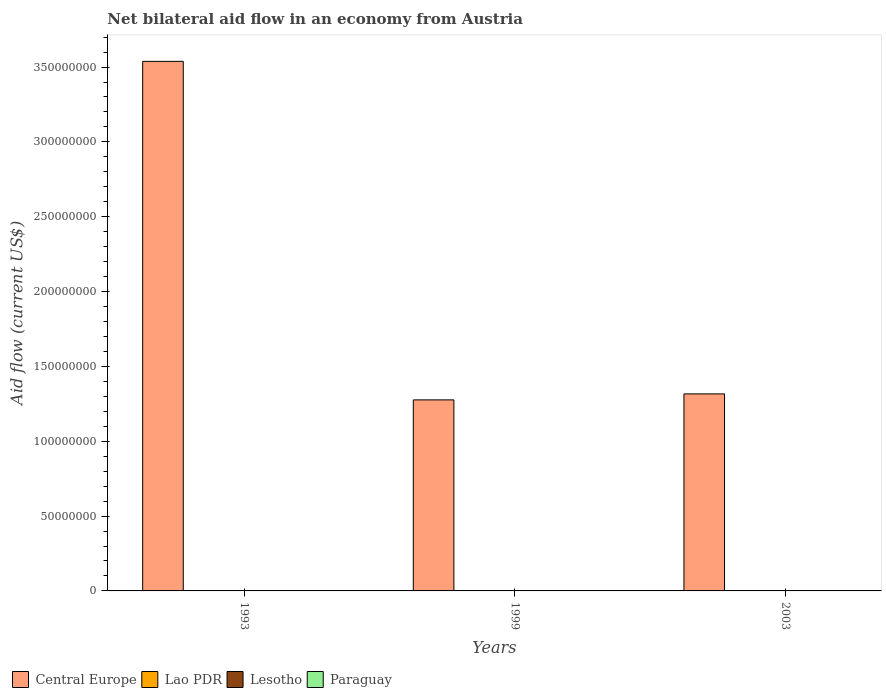Are the number of bars on each tick of the X-axis equal?
Keep it short and to the point. Yes. How many bars are there on the 1st tick from the left?
Ensure brevity in your answer.  4. What is the label of the 1st group of bars from the left?
Provide a short and direct response. 1993. Across all years, what is the maximum net bilateral aid flow in Lesotho?
Make the answer very short. 1.00e+05. Across all years, what is the minimum net bilateral aid flow in Paraguay?
Offer a very short reply. 10000. In which year was the net bilateral aid flow in Lao PDR maximum?
Your answer should be compact. 1993. In which year was the net bilateral aid flow in Paraguay minimum?
Your answer should be compact. 2003. What is the total net bilateral aid flow in Central Europe in the graph?
Your response must be concise. 6.13e+08. What is the average net bilateral aid flow in Lao PDR per year?
Your answer should be very brief. 6.00e+04. In the year 2003, what is the difference between the net bilateral aid flow in Lao PDR and net bilateral aid flow in Lesotho?
Your response must be concise. -8.00e+04. What is the ratio of the net bilateral aid flow in Lao PDR in 1999 to that in 2003?
Your answer should be compact. 0.5. Is the net bilateral aid flow in Lao PDR in 1993 less than that in 1999?
Make the answer very short. No. Is the difference between the net bilateral aid flow in Lao PDR in 1993 and 1999 greater than the difference between the net bilateral aid flow in Lesotho in 1993 and 1999?
Ensure brevity in your answer.  Yes. Is the sum of the net bilateral aid flow in Central Europe in 1999 and 2003 greater than the maximum net bilateral aid flow in Lao PDR across all years?
Make the answer very short. Yes. What does the 3rd bar from the left in 2003 represents?
Your answer should be very brief. Lesotho. What does the 4th bar from the right in 1999 represents?
Ensure brevity in your answer.  Central Europe. Is it the case that in every year, the sum of the net bilateral aid flow in Paraguay and net bilateral aid flow in Lao PDR is greater than the net bilateral aid flow in Central Europe?
Offer a very short reply. No. Are all the bars in the graph horizontal?
Make the answer very short. No. How many years are there in the graph?
Ensure brevity in your answer.  3. What is the difference between two consecutive major ticks on the Y-axis?
Keep it short and to the point. 5.00e+07. Are the values on the major ticks of Y-axis written in scientific E-notation?
Make the answer very short. No. Does the graph contain any zero values?
Offer a very short reply. No. Where does the legend appear in the graph?
Ensure brevity in your answer.  Bottom left. How many legend labels are there?
Your answer should be compact. 4. What is the title of the graph?
Your response must be concise. Net bilateral aid flow in an economy from Austria. Does "Guinea-Bissau" appear as one of the legend labels in the graph?
Give a very brief answer. No. What is the label or title of the Y-axis?
Your answer should be very brief. Aid flow (current US$). What is the Aid flow (current US$) of Central Europe in 1993?
Provide a short and direct response. 3.54e+08. What is the Aid flow (current US$) in Paraguay in 1993?
Your response must be concise. 3.00e+04. What is the Aid flow (current US$) of Central Europe in 1999?
Your response must be concise. 1.28e+08. What is the Aid flow (current US$) in Lao PDR in 1999?
Offer a terse response. 10000. What is the Aid flow (current US$) of Lesotho in 1999?
Offer a very short reply. 2.00e+04. What is the Aid flow (current US$) in Central Europe in 2003?
Give a very brief answer. 1.32e+08. What is the Aid flow (current US$) of Lao PDR in 2003?
Offer a very short reply. 2.00e+04. What is the Aid flow (current US$) of Lesotho in 2003?
Provide a short and direct response. 1.00e+05. Across all years, what is the maximum Aid flow (current US$) in Central Europe?
Your answer should be very brief. 3.54e+08. Across all years, what is the maximum Aid flow (current US$) of Lesotho?
Make the answer very short. 1.00e+05. Across all years, what is the maximum Aid flow (current US$) in Paraguay?
Provide a short and direct response. 3.00e+04. Across all years, what is the minimum Aid flow (current US$) of Central Europe?
Offer a terse response. 1.28e+08. Across all years, what is the minimum Aid flow (current US$) in Lesotho?
Keep it short and to the point. 2.00e+04. What is the total Aid flow (current US$) in Central Europe in the graph?
Ensure brevity in your answer.  6.13e+08. What is the total Aid flow (current US$) of Paraguay in the graph?
Offer a terse response. 6.00e+04. What is the difference between the Aid flow (current US$) in Central Europe in 1993 and that in 1999?
Your answer should be compact. 2.26e+08. What is the difference between the Aid flow (current US$) of Central Europe in 1993 and that in 2003?
Keep it short and to the point. 2.22e+08. What is the difference between the Aid flow (current US$) in Lao PDR in 1993 and that in 2003?
Make the answer very short. 1.30e+05. What is the difference between the Aid flow (current US$) in Lesotho in 1993 and that in 2003?
Your answer should be very brief. -8.00e+04. What is the difference between the Aid flow (current US$) of Paraguay in 1993 and that in 2003?
Make the answer very short. 2.00e+04. What is the difference between the Aid flow (current US$) in Central Europe in 1999 and that in 2003?
Give a very brief answer. -4.00e+06. What is the difference between the Aid flow (current US$) of Lao PDR in 1999 and that in 2003?
Keep it short and to the point. -10000. What is the difference between the Aid flow (current US$) of Paraguay in 1999 and that in 2003?
Your answer should be very brief. 10000. What is the difference between the Aid flow (current US$) of Central Europe in 1993 and the Aid flow (current US$) of Lao PDR in 1999?
Make the answer very short. 3.54e+08. What is the difference between the Aid flow (current US$) of Central Europe in 1993 and the Aid flow (current US$) of Lesotho in 1999?
Offer a very short reply. 3.54e+08. What is the difference between the Aid flow (current US$) of Central Europe in 1993 and the Aid flow (current US$) of Paraguay in 1999?
Provide a succinct answer. 3.54e+08. What is the difference between the Aid flow (current US$) of Lao PDR in 1993 and the Aid flow (current US$) of Lesotho in 1999?
Your response must be concise. 1.30e+05. What is the difference between the Aid flow (current US$) in Lao PDR in 1993 and the Aid flow (current US$) in Paraguay in 1999?
Make the answer very short. 1.30e+05. What is the difference between the Aid flow (current US$) in Central Europe in 1993 and the Aid flow (current US$) in Lao PDR in 2003?
Your answer should be very brief. 3.54e+08. What is the difference between the Aid flow (current US$) of Central Europe in 1993 and the Aid flow (current US$) of Lesotho in 2003?
Provide a succinct answer. 3.54e+08. What is the difference between the Aid flow (current US$) of Central Europe in 1993 and the Aid flow (current US$) of Paraguay in 2003?
Provide a short and direct response. 3.54e+08. What is the difference between the Aid flow (current US$) in Lao PDR in 1993 and the Aid flow (current US$) in Lesotho in 2003?
Provide a succinct answer. 5.00e+04. What is the difference between the Aid flow (current US$) in Central Europe in 1999 and the Aid flow (current US$) in Lao PDR in 2003?
Keep it short and to the point. 1.28e+08. What is the difference between the Aid flow (current US$) in Central Europe in 1999 and the Aid flow (current US$) in Lesotho in 2003?
Ensure brevity in your answer.  1.28e+08. What is the difference between the Aid flow (current US$) of Central Europe in 1999 and the Aid flow (current US$) of Paraguay in 2003?
Ensure brevity in your answer.  1.28e+08. What is the difference between the Aid flow (current US$) in Lao PDR in 1999 and the Aid flow (current US$) in Lesotho in 2003?
Your answer should be very brief. -9.00e+04. What is the average Aid flow (current US$) in Central Europe per year?
Your answer should be compact. 2.04e+08. What is the average Aid flow (current US$) in Lesotho per year?
Offer a terse response. 4.67e+04. What is the average Aid flow (current US$) of Paraguay per year?
Your answer should be very brief. 2.00e+04. In the year 1993, what is the difference between the Aid flow (current US$) in Central Europe and Aid flow (current US$) in Lao PDR?
Your answer should be very brief. 3.54e+08. In the year 1993, what is the difference between the Aid flow (current US$) in Central Europe and Aid flow (current US$) in Lesotho?
Ensure brevity in your answer.  3.54e+08. In the year 1993, what is the difference between the Aid flow (current US$) in Central Europe and Aid flow (current US$) in Paraguay?
Make the answer very short. 3.54e+08. In the year 1993, what is the difference between the Aid flow (current US$) of Lao PDR and Aid flow (current US$) of Lesotho?
Your response must be concise. 1.30e+05. In the year 1993, what is the difference between the Aid flow (current US$) in Lesotho and Aid flow (current US$) in Paraguay?
Offer a very short reply. -10000. In the year 1999, what is the difference between the Aid flow (current US$) in Central Europe and Aid flow (current US$) in Lao PDR?
Provide a short and direct response. 1.28e+08. In the year 1999, what is the difference between the Aid flow (current US$) of Central Europe and Aid flow (current US$) of Lesotho?
Your response must be concise. 1.28e+08. In the year 1999, what is the difference between the Aid flow (current US$) in Central Europe and Aid flow (current US$) in Paraguay?
Offer a terse response. 1.28e+08. In the year 2003, what is the difference between the Aid flow (current US$) of Central Europe and Aid flow (current US$) of Lao PDR?
Ensure brevity in your answer.  1.32e+08. In the year 2003, what is the difference between the Aid flow (current US$) of Central Europe and Aid flow (current US$) of Lesotho?
Provide a short and direct response. 1.32e+08. In the year 2003, what is the difference between the Aid flow (current US$) in Central Europe and Aid flow (current US$) in Paraguay?
Provide a short and direct response. 1.32e+08. In the year 2003, what is the difference between the Aid flow (current US$) in Lao PDR and Aid flow (current US$) in Lesotho?
Keep it short and to the point. -8.00e+04. In the year 2003, what is the difference between the Aid flow (current US$) of Lao PDR and Aid flow (current US$) of Paraguay?
Provide a succinct answer. 10000. In the year 2003, what is the difference between the Aid flow (current US$) in Lesotho and Aid flow (current US$) in Paraguay?
Keep it short and to the point. 9.00e+04. What is the ratio of the Aid flow (current US$) of Central Europe in 1993 to that in 1999?
Provide a succinct answer. 2.77. What is the ratio of the Aid flow (current US$) of Lesotho in 1993 to that in 1999?
Make the answer very short. 1. What is the ratio of the Aid flow (current US$) in Paraguay in 1993 to that in 1999?
Offer a very short reply. 1.5. What is the ratio of the Aid flow (current US$) in Central Europe in 1993 to that in 2003?
Your answer should be compact. 2.69. What is the ratio of the Aid flow (current US$) in Paraguay in 1993 to that in 2003?
Your answer should be very brief. 3. What is the ratio of the Aid flow (current US$) of Central Europe in 1999 to that in 2003?
Make the answer very short. 0.97. What is the ratio of the Aid flow (current US$) in Lao PDR in 1999 to that in 2003?
Your answer should be very brief. 0.5. What is the ratio of the Aid flow (current US$) in Paraguay in 1999 to that in 2003?
Your answer should be compact. 2. What is the difference between the highest and the second highest Aid flow (current US$) of Central Europe?
Make the answer very short. 2.22e+08. What is the difference between the highest and the second highest Aid flow (current US$) in Lao PDR?
Your answer should be compact. 1.30e+05. What is the difference between the highest and the second highest Aid flow (current US$) in Lesotho?
Your response must be concise. 8.00e+04. What is the difference between the highest and the lowest Aid flow (current US$) of Central Europe?
Keep it short and to the point. 2.26e+08. What is the difference between the highest and the lowest Aid flow (current US$) of Lesotho?
Provide a succinct answer. 8.00e+04. What is the difference between the highest and the lowest Aid flow (current US$) of Paraguay?
Offer a terse response. 2.00e+04. 